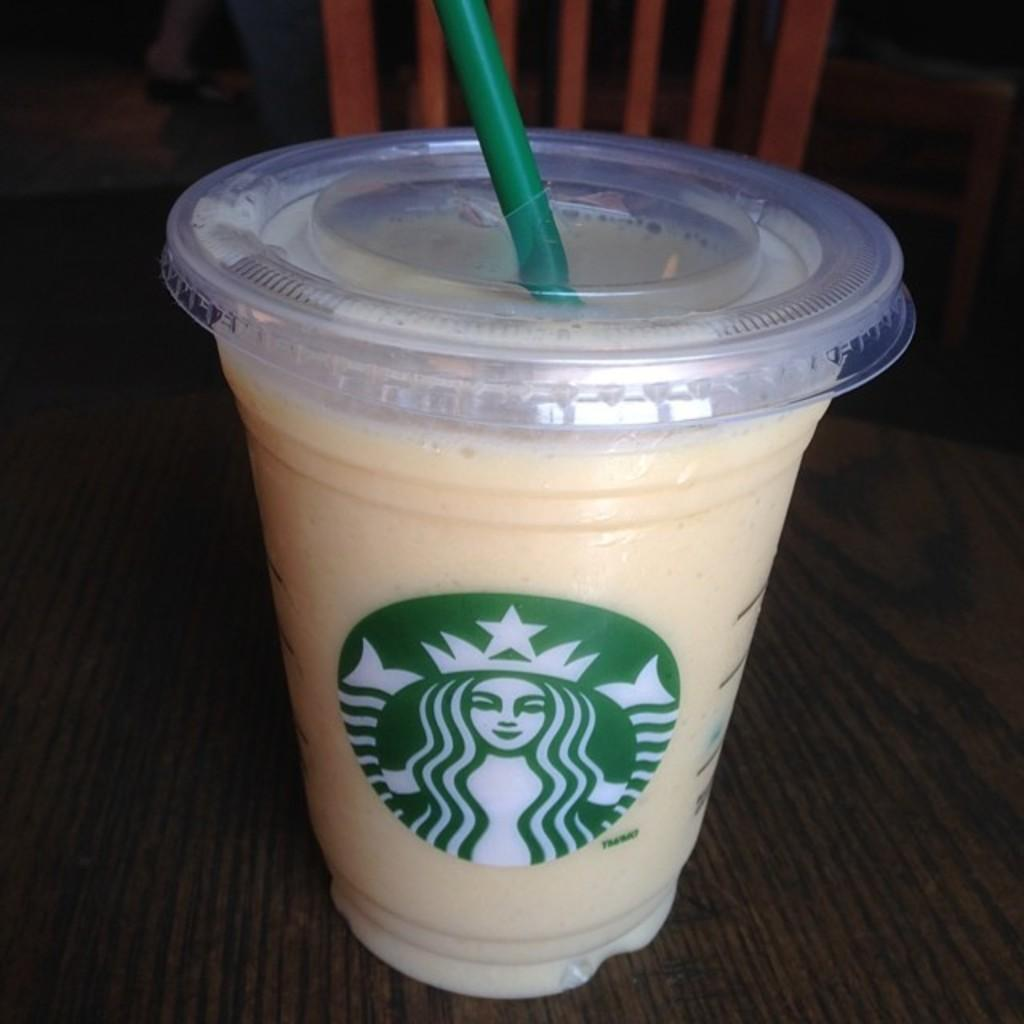What is present on the table in the image? There is a coffee mug in the image. What feature does the coffee mug have? The coffee mug has a straw. Where is the coffee mug located? The coffee mug is on a table. What type of music does the goose play in the image? There is no goose or music present in the image. 